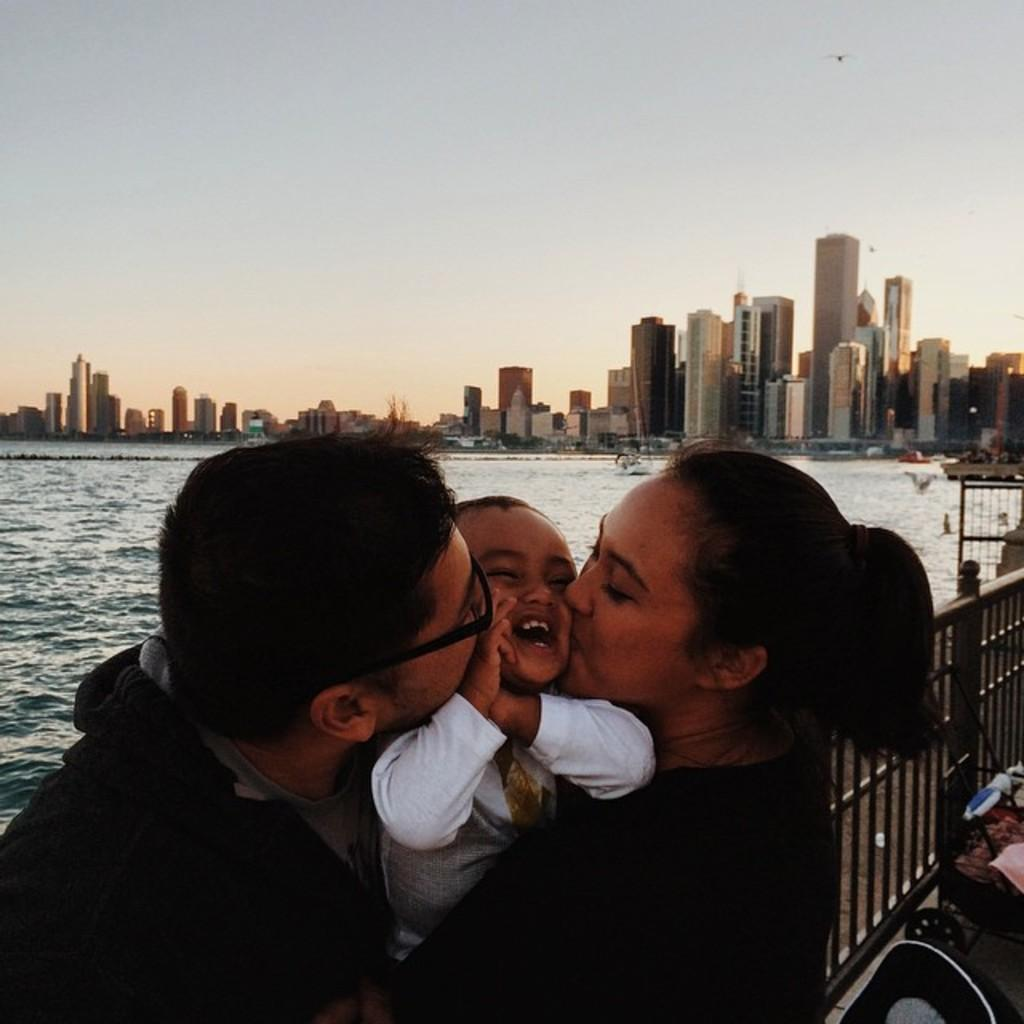Who is in the image? There is a couple in the image. What are the couple doing in the image? The couple is kissing a child. What is located behind the couple? There is a metal fence in the image, and water is visible behind the fence. What can be seen in the distance in the image? There are buildings in the background of the image. What type of curve can be seen in the image? There is no curve present in the image. How many cars are visible in the image? There are no cars visible in the image. 